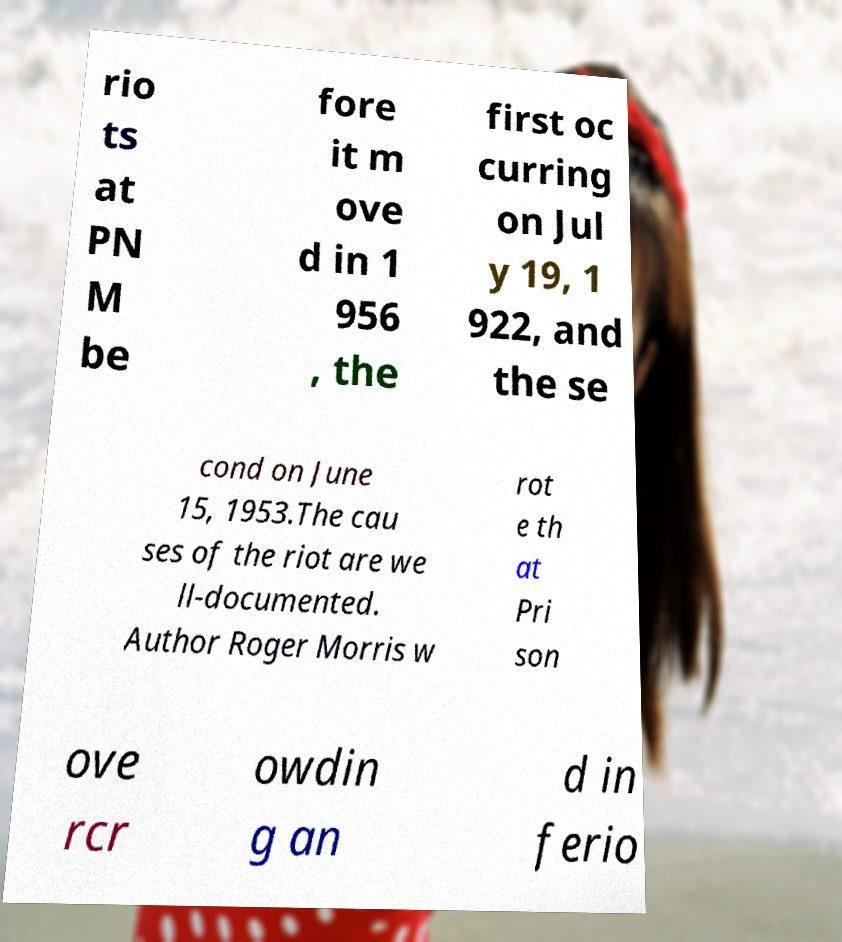Please identify and transcribe the text found in this image. rio ts at PN M be fore it m ove d in 1 956 , the first oc curring on Jul y 19, 1 922, and the se cond on June 15, 1953.The cau ses of the riot are we ll-documented. Author Roger Morris w rot e th at Pri son ove rcr owdin g an d in ferio 